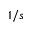<formula> <loc_0><loc_0><loc_500><loc_500>1 / s</formula> 